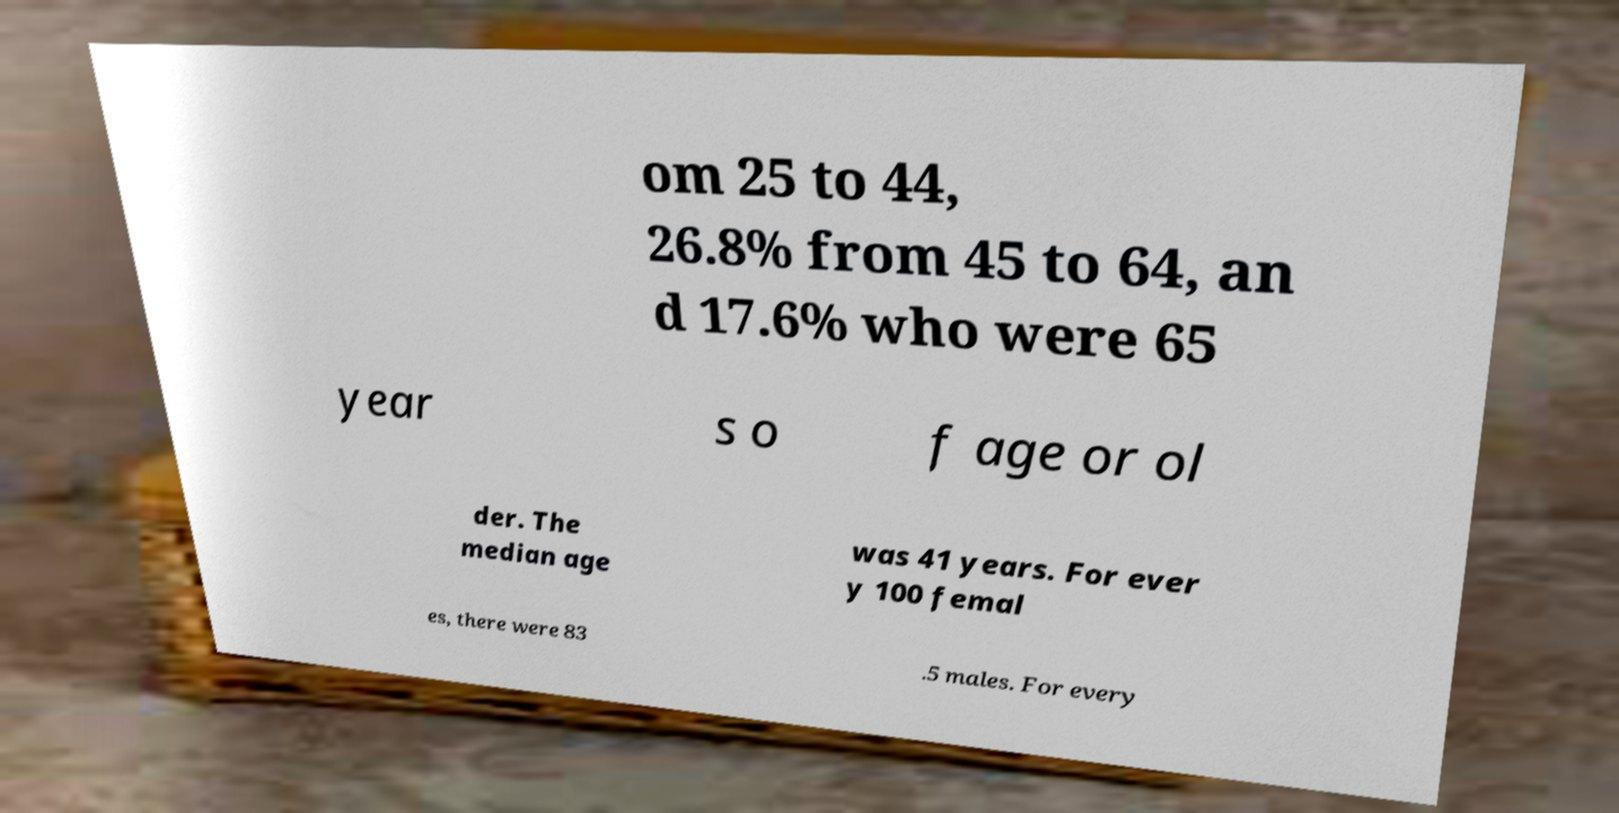I need the written content from this picture converted into text. Can you do that? om 25 to 44, 26.8% from 45 to 64, an d 17.6% who were 65 year s o f age or ol der. The median age was 41 years. For ever y 100 femal es, there were 83 .5 males. For every 